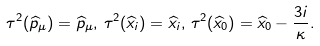<formula> <loc_0><loc_0><loc_500><loc_500>\tau ^ { 2 } ( \widehat { p } _ { \mu } ) = \widehat { p } _ { \mu } , \, \tau ^ { 2 } ( \widehat { x } _ { i } ) = \widehat { x } _ { i } , \, \tau ^ { 2 } ( \widehat { x } _ { 0 } ) = \widehat { x } _ { 0 } - \frac { 3 i } { \kappa } .</formula> 